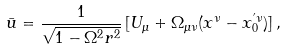Convert formula to latex. <formula><loc_0><loc_0><loc_500><loc_500>\bar { u } = \frac { 1 } { \sqrt { 1 - \Omega ^ { 2 } r ^ { 2 } } } \, [ U _ { \mu } + \Omega _ { \mu \nu } ( x ^ { \nu } - x _ { 0 } ^ { ^ { \prime } \nu } ) ] \, ,</formula> 